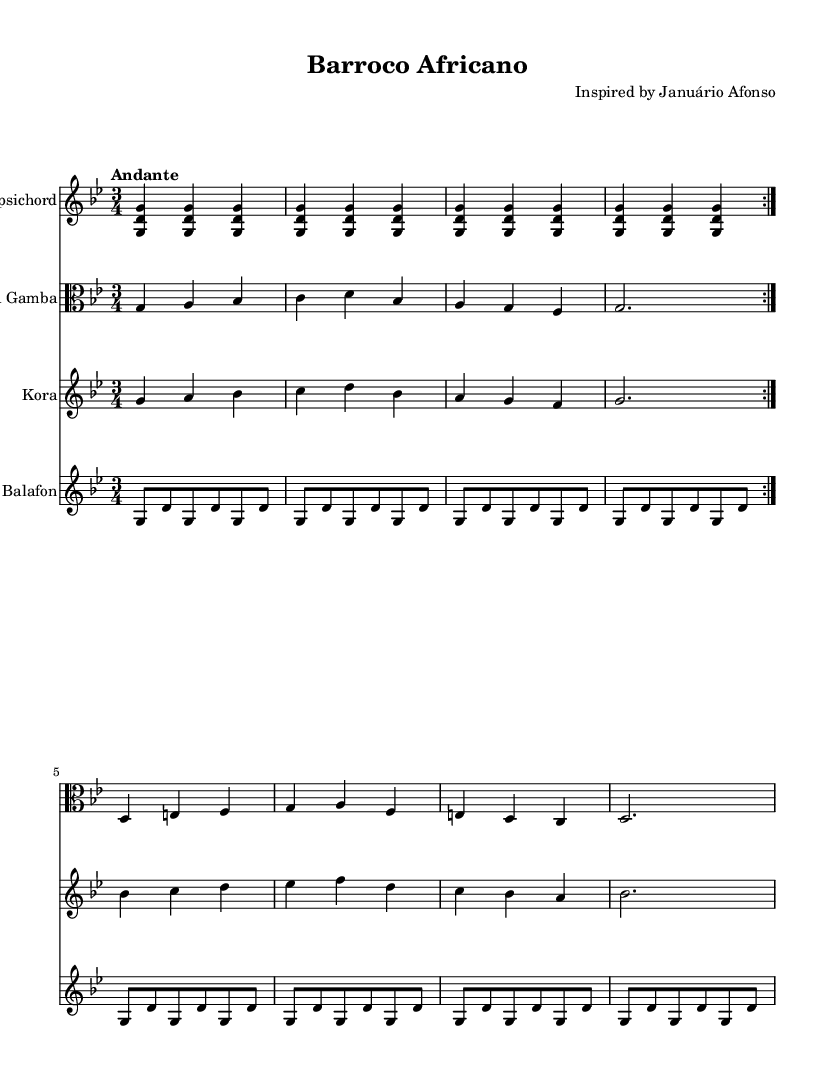What is the key signature of this music? The key signature is G minor, which has two flats (B flat and E flat).
Answer: G minor What is the time signature of the piece? The time signature is 3/4, which indicates three beats per measure and a quarter note gets one beat.
Answer: 3/4 What is the tempo marking given for the piece? The tempo marking is "Andante", which suggests a moderately slow tempo.
Answer: Andante How many instruments are featured in this chamber music piece? There are four instruments featured: Harpsichord, Viola da Gamba, Kora, and Balafon.
Answer: Four What type of form does the Harpsichord part exhibit? The Harpsichord part exhibits a repeat structure, as indicated by the "repeat volta 2".
Answer: Repeat structure What do the rhythmic values of the Harpsichord part indicate about the piece's character? The rhythmic values are consistent quarter notes, suggesting a steady, flowing character appropriate for Baroque styles.
Answer: Steady, flowing character What traditional African instrument is included in the ensemble? The Kora is a traditional African instrument featured in the ensemble.
Answer: Kora 